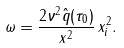Convert formula to latex. <formula><loc_0><loc_0><loc_500><loc_500>\omega = \frac { 2 \nu ^ { 2 } \hat { q } ( \tau _ { 0 } ) } { x ^ { 2 } } \, x ^ { 2 } _ { i } .</formula> 